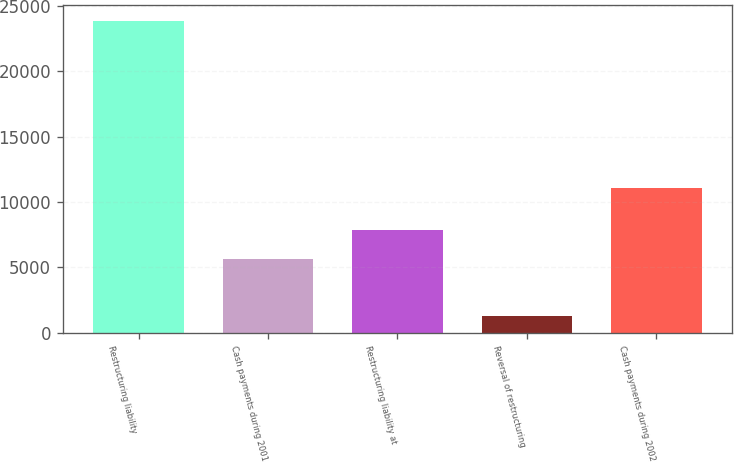<chart> <loc_0><loc_0><loc_500><loc_500><bar_chart><fcel>Restructuring liability<fcel>Cash payments during 2001<fcel>Restructuring liability at<fcel>Reversal of restructuring<fcel>Cash payments during 2002<nl><fcel>23877<fcel>5644<fcel>7903.2<fcel>1285<fcel>11118<nl></chart> 